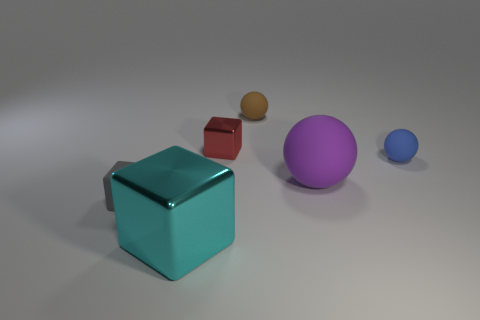Subtract all red metallic cubes. How many cubes are left? 2 Subtract 2 balls. How many balls are left? 1 Add 2 large gray spheres. How many objects exist? 8 Subtract all cyan blocks. How many blocks are left? 2 Subtract all brown blocks. Subtract all red cylinders. How many blocks are left? 3 Subtract all red cylinders. How many red spheres are left? 0 Subtract all blue matte spheres. Subtract all tiny rubber blocks. How many objects are left? 4 Add 6 brown balls. How many brown balls are left? 7 Add 6 red metallic spheres. How many red metallic spheres exist? 6 Subtract 1 gray blocks. How many objects are left? 5 